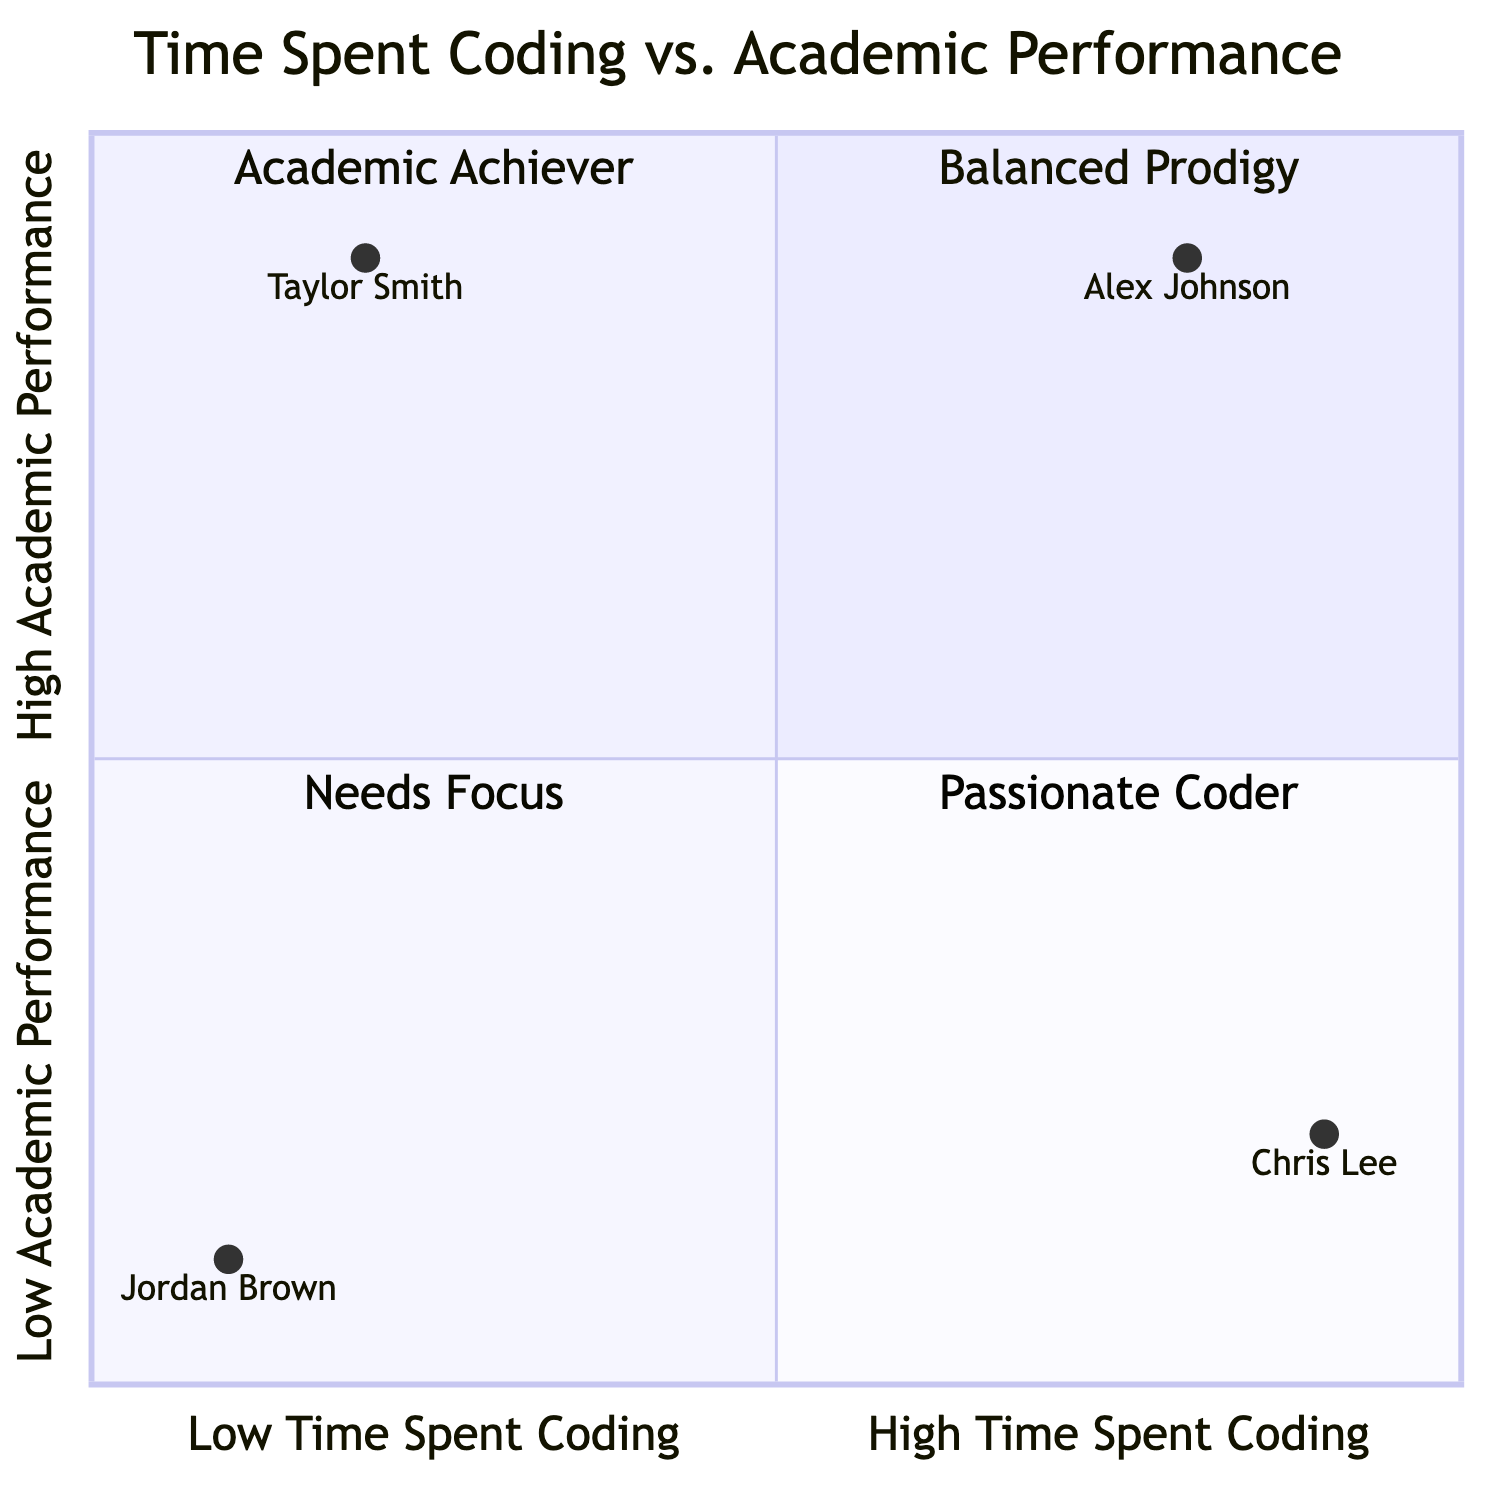What are the names of the two individuals in the Balanced Prodigy quadrant? The Balanced Prodigy quadrant features a single individual, Alex Johnson. This can be confirmed by identifying the quadrant, which lists examples, and reading the name of the example within that section.
Answer: Alex Johnson How many individuals are represented in the Passionate Coder quadrant? The Passionate Coder quadrant contains one individual, Chris Lee. This can be determined by looking at the number of examples listed in that specific quadrant.
Answer: One What is the highest academic performance grade recorded among the individuals? The highest academic performance grades recorded are A in both Math and Computer Science for Alex Johnson. This is assessed by examining the grades listed under each individual in the quad chart.
Answer: A Which individual has the lowest time spent coding score? The individual with the lowest time spent coding score is Jordan Brown, with a score of 0.1. This is determined by comparing the coding scores associated with each individual in the chart.
Answer: Jordan Brown In which quadrant is Taylor Smith located? Taylor Smith is located in the Academic Achiever quadrant. This can be confirmed by referencing the name assigned to the quadrant and checking the examples provided for that section.
Answer: Academic Achiever Which two quadrants represent high coding time? The two quadrants representing high coding time are Balanced Prodigy and Passionate Coder. This is derived from identifying the quadrants where time spent coding is classified as high according to the x-axis definition.
Answer: Balanced Prodigy, Passionate Coder What is the coding project associated with Chris Lee? Chris Lee is associated with two coding projects: AI Chatbot and Social Media Platform. This is found by referring to the examples provided in the Passionate Coder quadrant.
Answer: AI Chatbot, Social Media Platform Which student shows evidence of needing better time management skills? Chris Lee shows evidence of needing better time management skills, as indicated in the notes section associated with him in the Passionate Coder quadrant.
Answer: Chris Lee How is the performance of Jordan Brown described? Jordan Brown's performance is described as struggling in both coding and academics, which is specifically mentioned in the "Needs Focus" quadrant. This is understood by examining the description and notes provided in that section.
Answer: Struggling 